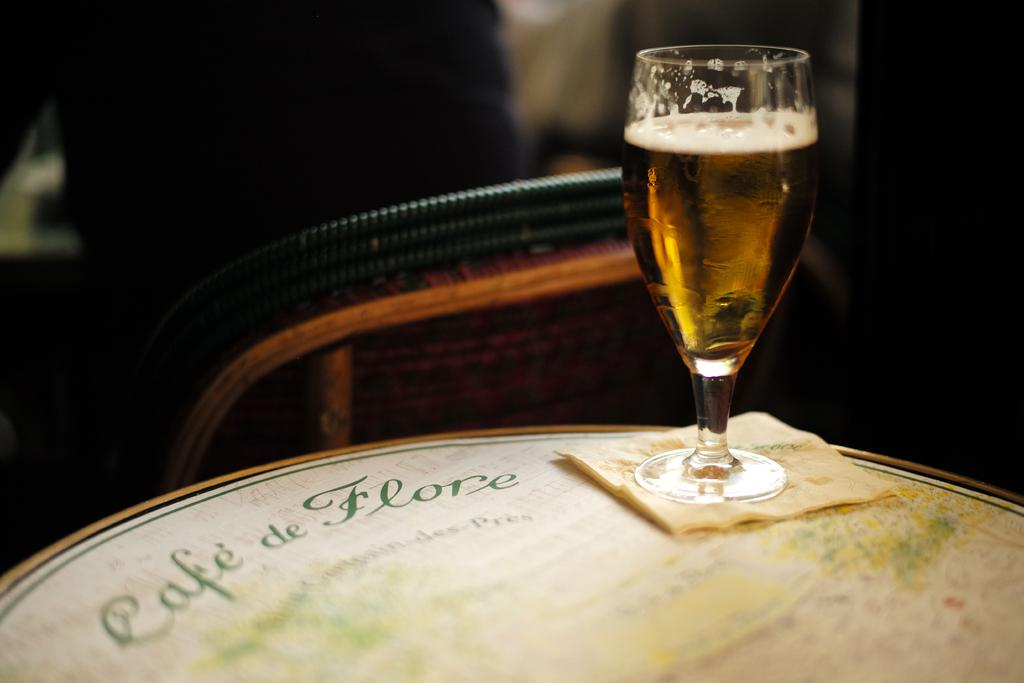What is in the glass that is visible in the image? There is a drink in the glass in the image. Where is the glass located? The glass is on a platform in the image. What else can be seen on the platform? There are objects on the platform in the image. How would you describe the overall lighting in the image? The background of the image is dark. What type of prison can be seen in the background of the image? There is no prison visible in the image; the background is dark, but no specific structures or locations are discernible. 